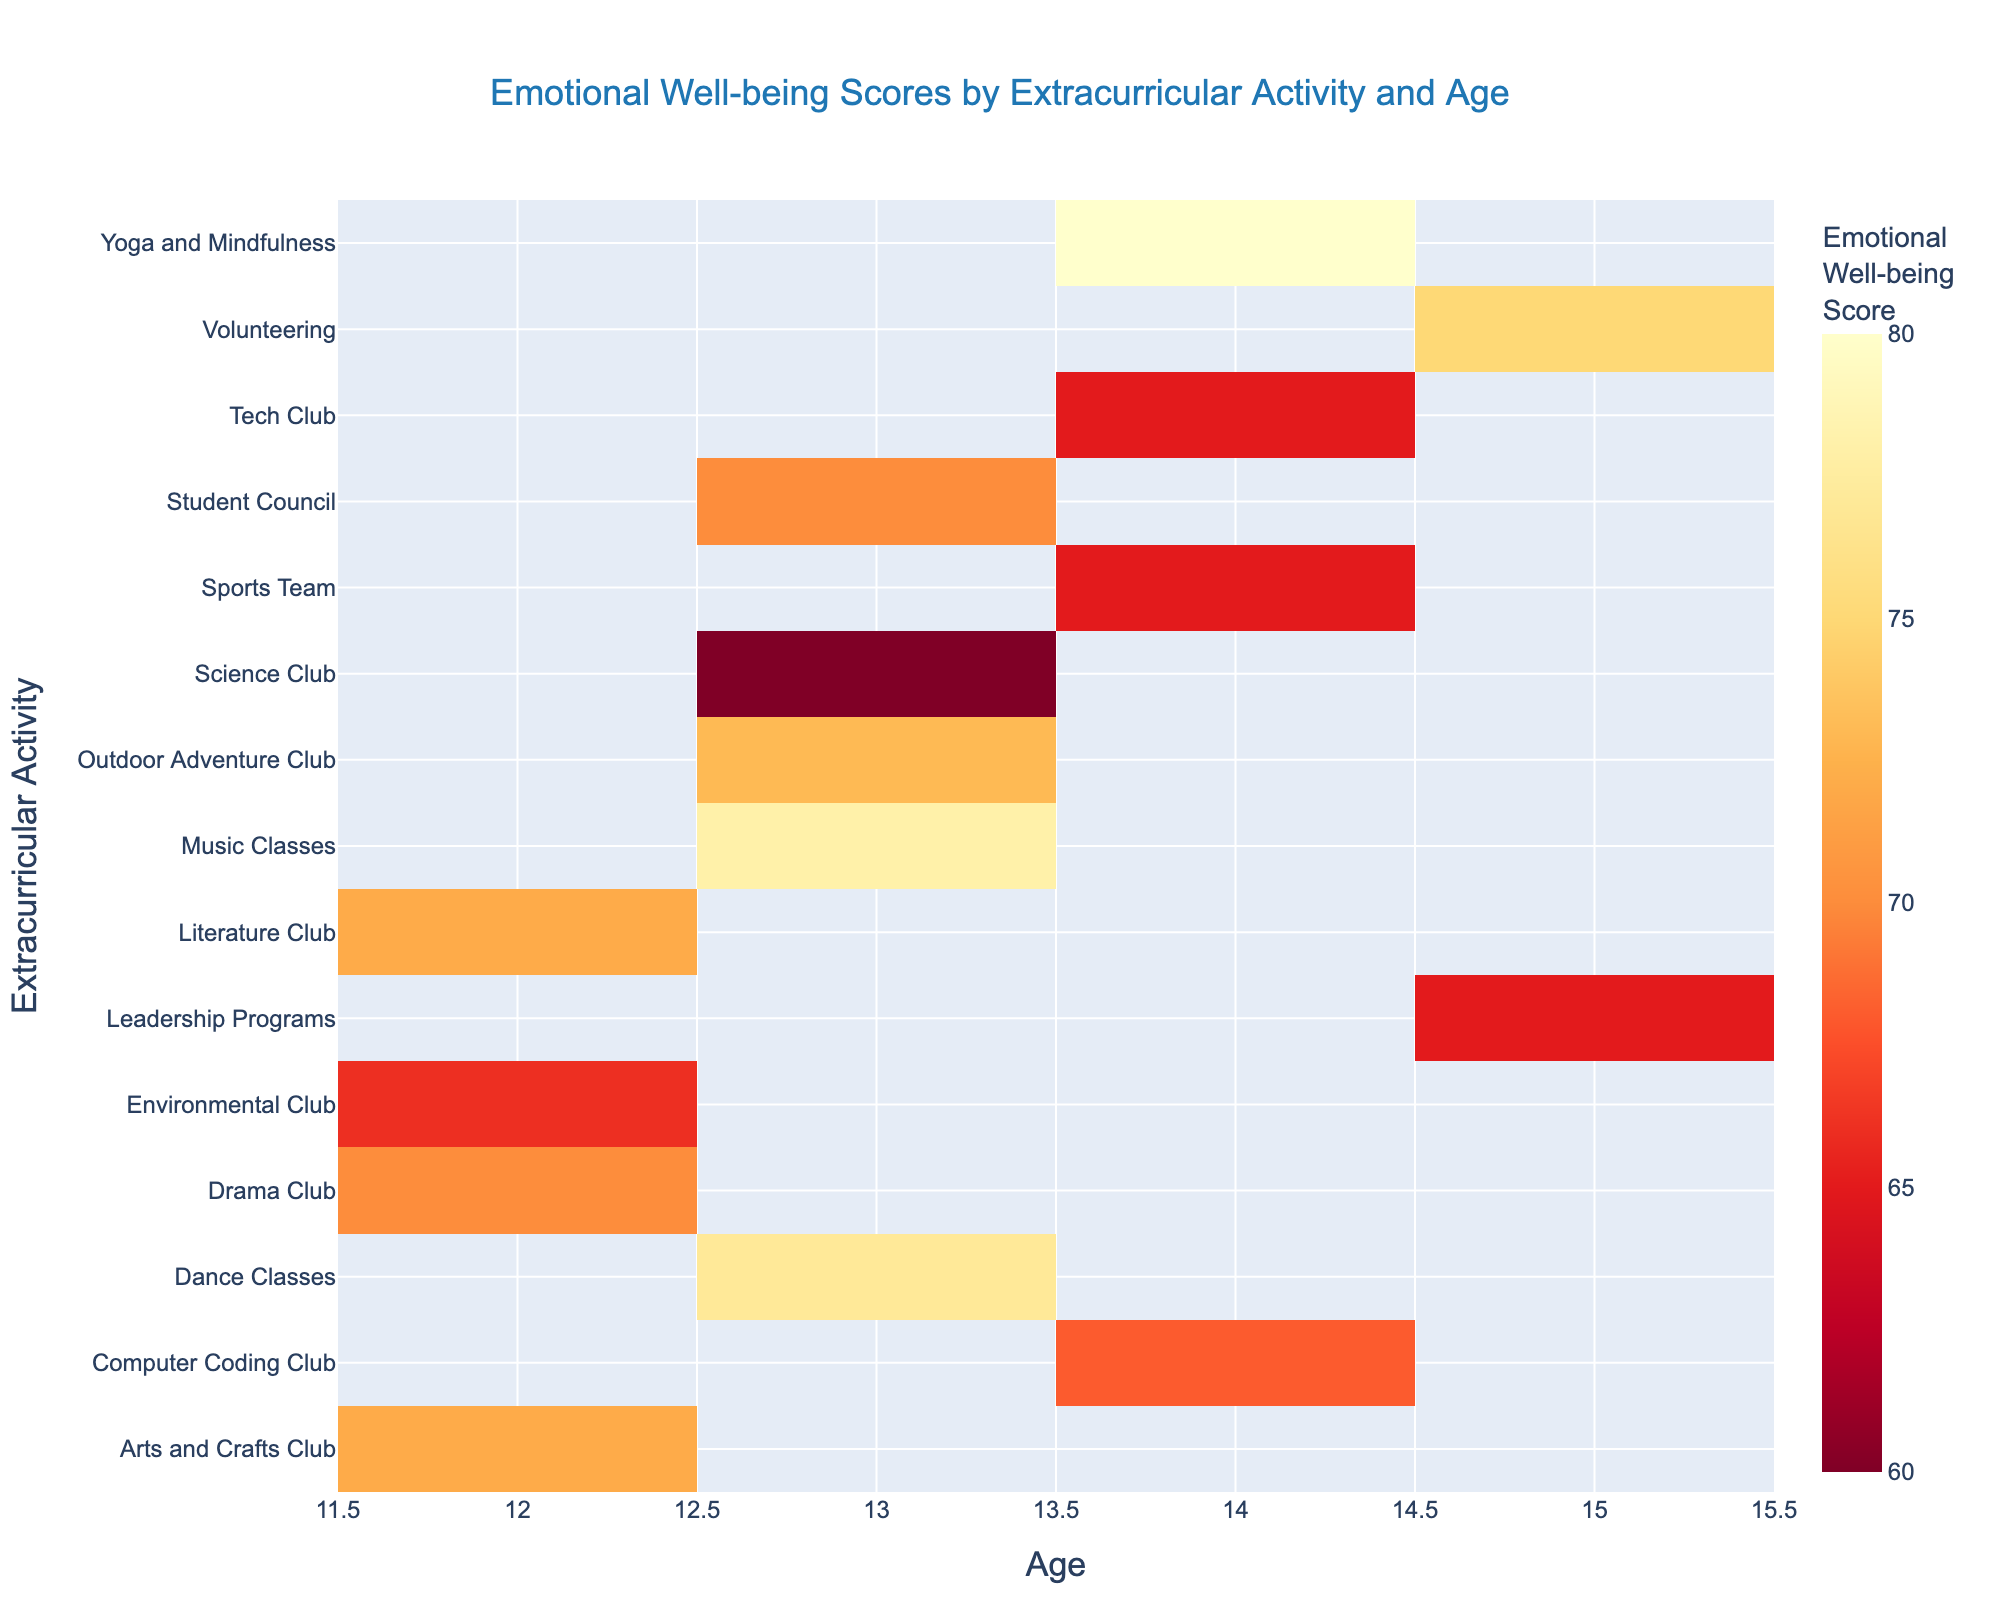What’s the title of the heatmap? The title of a heatmap is typically displayed at the top center of the figure. It provides the main description of what the heatmap is representing.
Answer: Emotional Well-being Scores by Extracurricular Activity and Age What is the average Emotional Well-being Score for age 14? To find the average, locate all the scores corresponding to age 14 and calculate their mean. The scores are 65 (Sports Team), 68 (Computer Coding Club), 80 (Yoga and Mindfulness), and 65 (Tech Club). Sum these scores and divide by the number of activities. (65+68+80+65)/4 = 69.5.
Answer: 69.5 Which extracurricular activities have the highest Emotional Well-being Score for age 13? Find all the scores corresponding to age 13 and identify the highest score. The scores are 78 (Music Classes), 60 (Science Club), 73 (Outdoor Adventure Club), 70 (Student Council), and 77 (Dance Classes). The highest is 78 for Music Classes.
Answer: Music Classes Which age group has the highest Emotional Well-being Score in the Yoga and Mindfulness activity? Look up the score for the Yoga and Mindfulness activity. For age 14, the score is 80, and this is the only score provided for this activity. Thus, age 14 has the highest score.
Answer: 14 Which activity has a score of 70 for 12-year-olds? Locate the scores corresponding to age 12 and identify the activity with a score of 70. The activities available are Drama Club (70) and Student Council (70). From the options, Drama Club has 70 for age 12.
Answer: Drama Club Is there any activity with an Emotional Well-being Score less than 65? Scan through all the scores in the heatmap to check for any score below 65. The given data shows all Emotional Well-being Scores are 60 or higher.
Answer: No Do 13-year-olds tend to have higher Emotional Well-being Scores in artistic activities or technical activities? Compare the average scores of artistic (Music Classes, Drama Club, Dance Classes) and technical activities (Science Club, Computer Coding Club, Tech Club) for 13-year-olds. Artistic: (78+70+77)/3 = 75. Technical: (60)/1 = 60. Thus, 13-year-olds tend to have higher scores in artistic activities.
Answer: Artistic activities What’s the Emotional Well-being Score for Volunteering for age 15? Locate the score for Volunteering under age 15. According to the data, the score is 75.
Answer: 75 